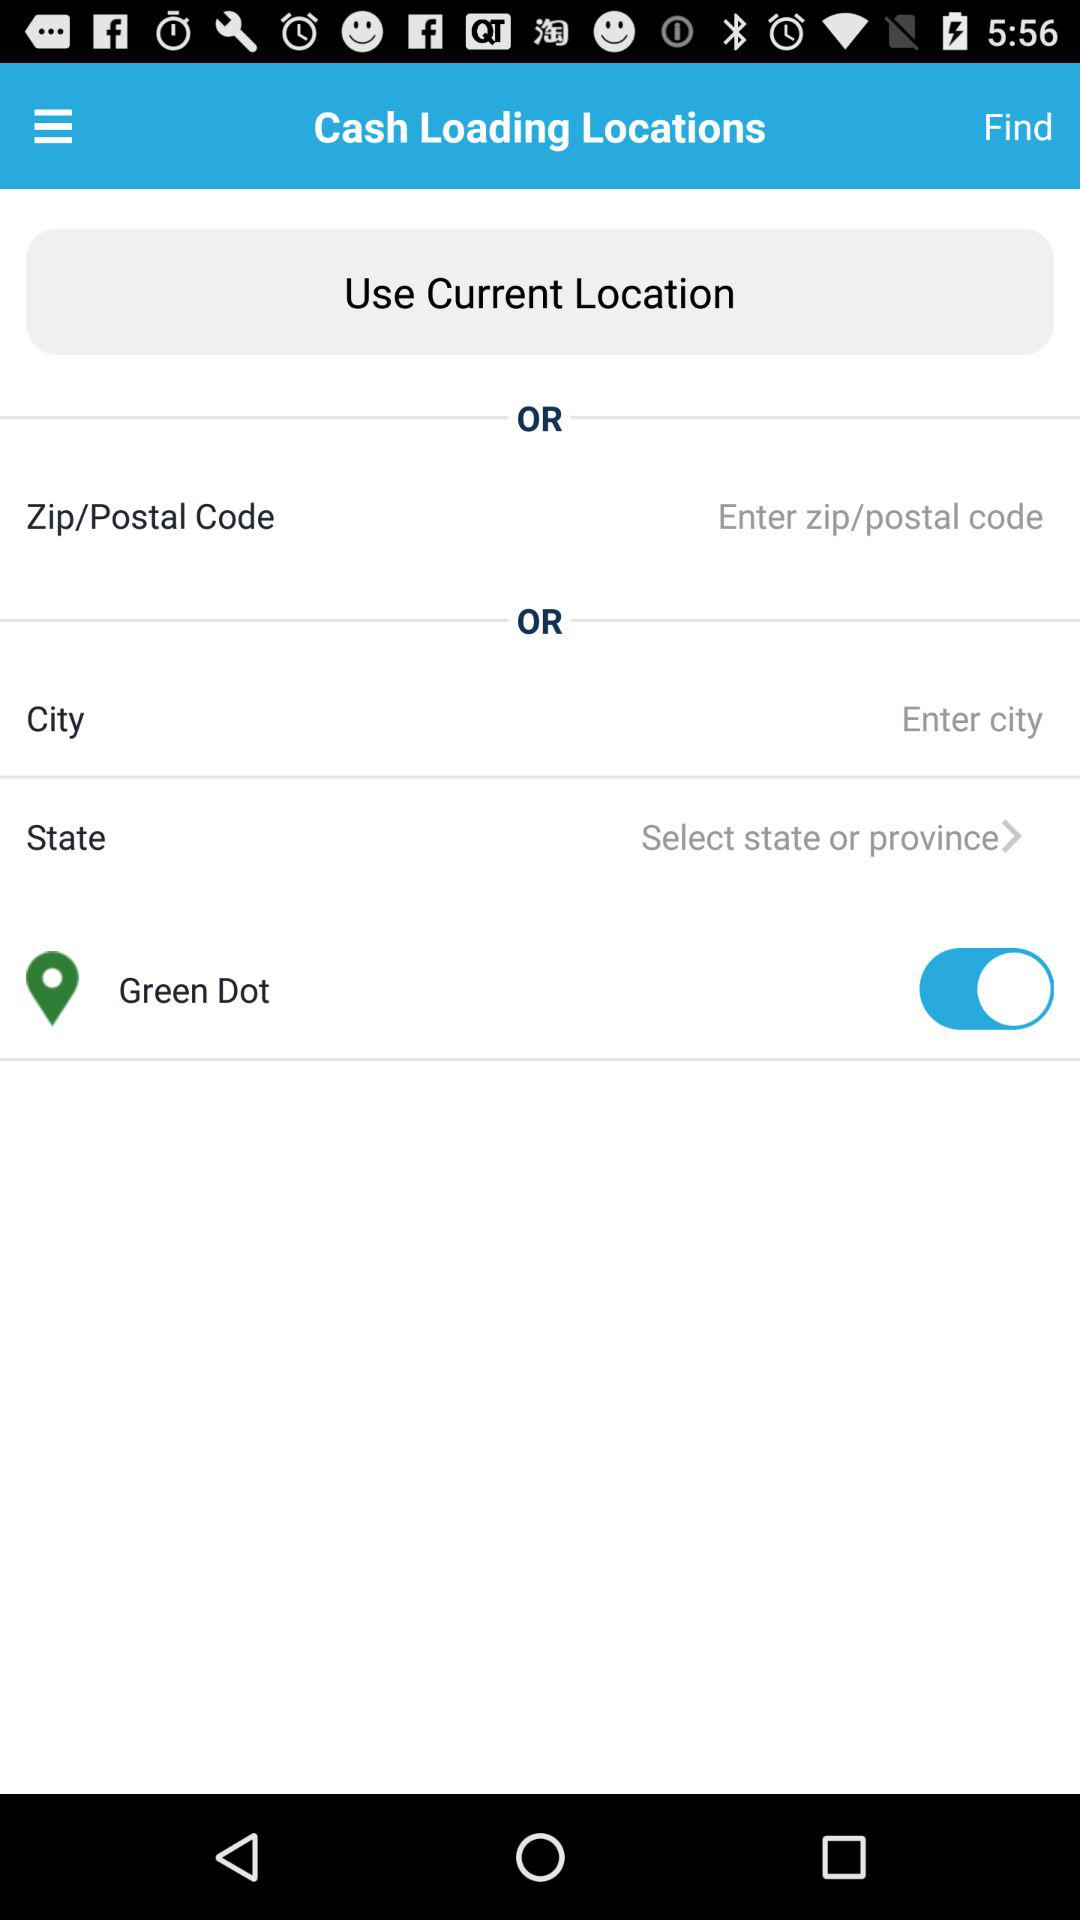What is the status of "Green Dot"? The status is "on". 